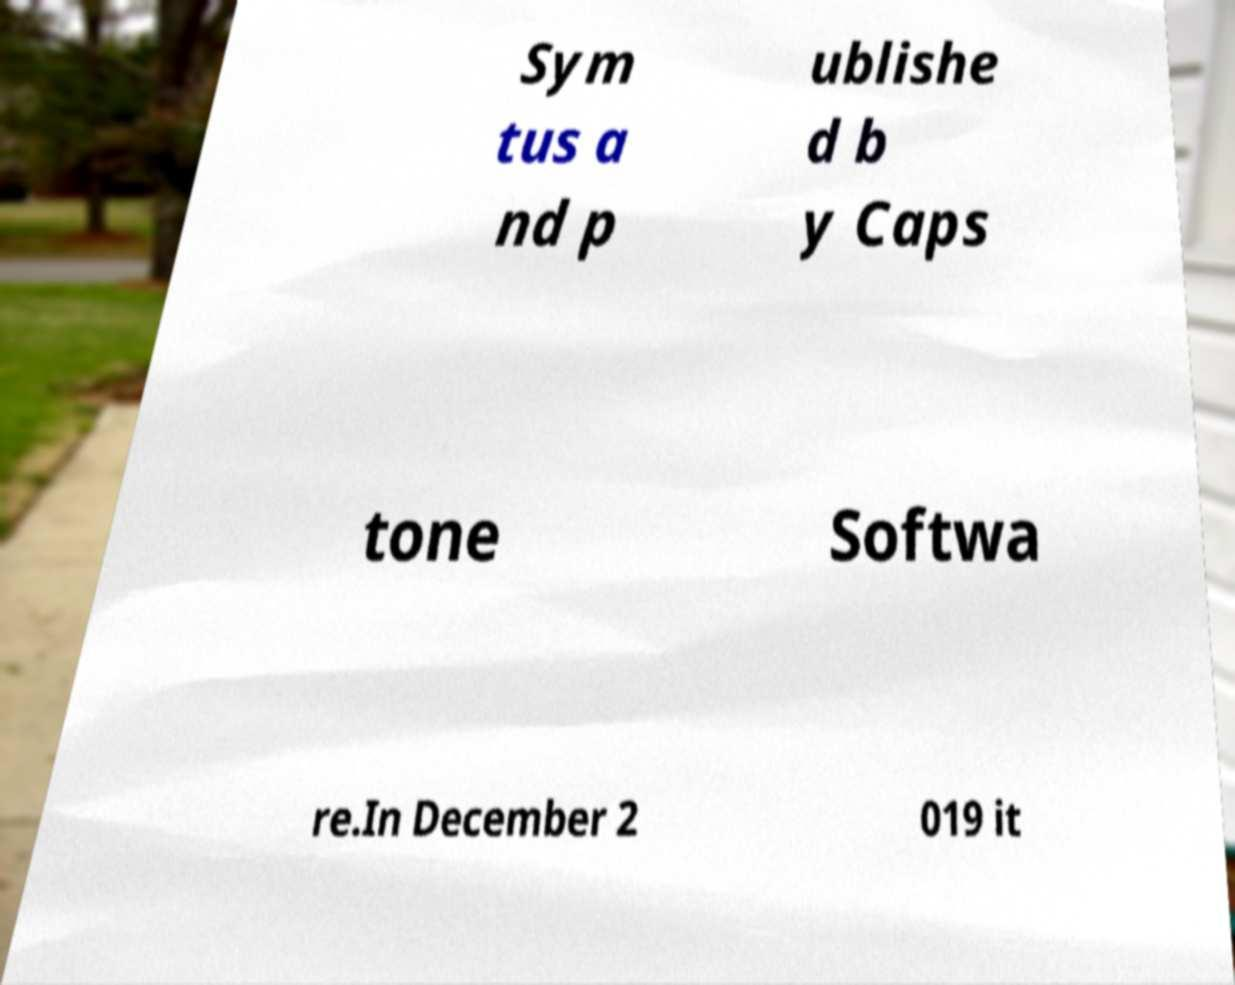Please identify and transcribe the text found in this image. Sym tus a nd p ublishe d b y Caps tone Softwa re.In December 2 019 it 